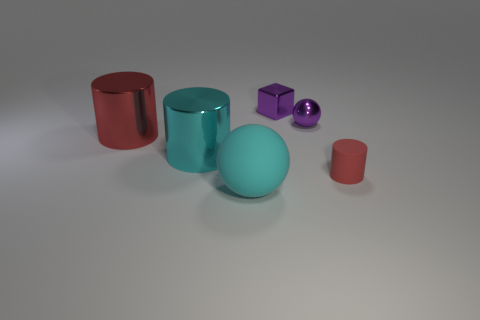There is a tiny purple thing that is made of the same material as the tiny sphere; what shape is it?
Provide a short and direct response. Cube. What is the red object on the left side of the object that is right of the sphere that is behind the large red metal cylinder made of?
Your response must be concise. Metal. Do the red matte cylinder and the cyan thing in front of the large cyan shiny cylinder have the same size?
Ensure brevity in your answer.  No. There is a tiny red thing that is the same shape as the big cyan metal thing; what is its material?
Offer a terse response. Rubber. There is a red cylinder that is in front of the red object to the left of the cylinder that is to the right of the cube; how big is it?
Provide a short and direct response. Small. Does the purple metal ball have the same size as the cyan metal object?
Offer a very short reply. No. There is a red thing that is on the left side of the big cyan object behind the cyan rubber object; what is its material?
Ensure brevity in your answer.  Metal. Do the red object behind the small cylinder and the matte object in front of the tiny cylinder have the same shape?
Offer a very short reply. No. Is the number of cyan metallic things that are to the right of the big cyan shiny cylinder the same as the number of purple metal cubes?
Offer a very short reply. No. There is a ball in front of the cyan cylinder; are there any cyan metallic cylinders right of it?
Provide a short and direct response. No. 